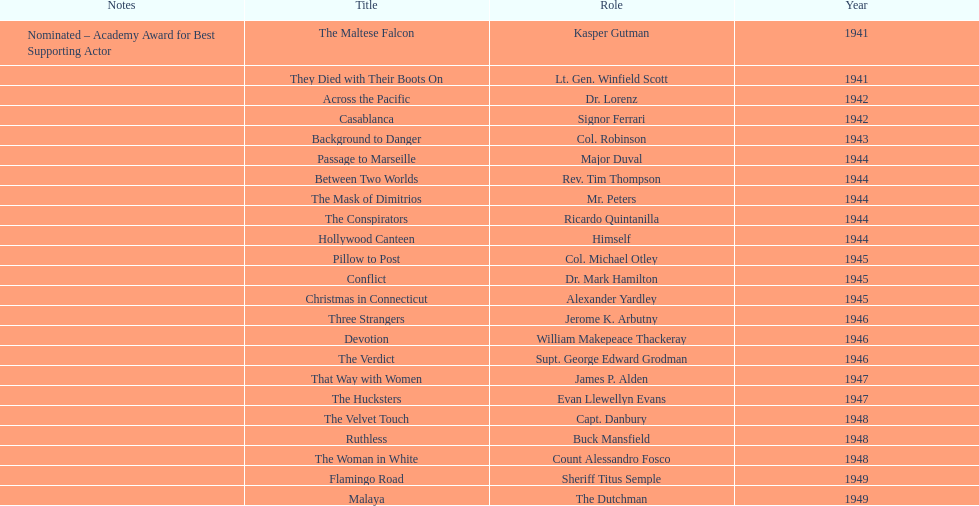How long did sydney greenstreet's acting career last? 9 years. Could you parse the entire table? {'header': ['Notes', 'Title', 'Role', 'Year'], 'rows': [['Nominated – Academy Award for Best Supporting Actor', 'The Maltese Falcon', 'Kasper Gutman', '1941'], ['', 'They Died with Their Boots On', 'Lt. Gen. Winfield Scott', '1941'], ['', 'Across the Pacific', 'Dr. Lorenz', '1942'], ['', 'Casablanca', 'Signor Ferrari', '1942'], ['', 'Background to Danger', 'Col. Robinson', '1943'], ['', 'Passage to Marseille', 'Major Duval', '1944'], ['', 'Between Two Worlds', 'Rev. Tim Thompson', '1944'], ['', 'The Mask of Dimitrios', 'Mr. Peters', '1944'], ['', 'The Conspirators', 'Ricardo Quintanilla', '1944'], ['', 'Hollywood Canteen', 'Himself', '1944'], ['', 'Pillow to Post', 'Col. Michael Otley', '1945'], ['', 'Conflict', 'Dr. Mark Hamilton', '1945'], ['', 'Christmas in Connecticut', 'Alexander Yardley', '1945'], ['', 'Three Strangers', 'Jerome K. Arbutny', '1946'], ['', 'Devotion', 'William Makepeace Thackeray', '1946'], ['', 'The Verdict', 'Supt. George Edward Grodman', '1946'], ['', 'That Way with Women', 'James P. Alden', '1947'], ['', 'The Hucksters', 'Evan Llewellyn Evans', '1947'], ['', 'The Velvet Touch', 'Capt. Danbury', '1948'], ['', 'Ruthless', 'Buck Mansfield', '1948'], ['', 'The Woman in White', 'Count Alessandro Fosco', '1948'], ['', 'Flamingo Road', 'Sheriff Titus Semple', '1949'], ['', 'Malaya', 'The Dutchman', '1949']]} 